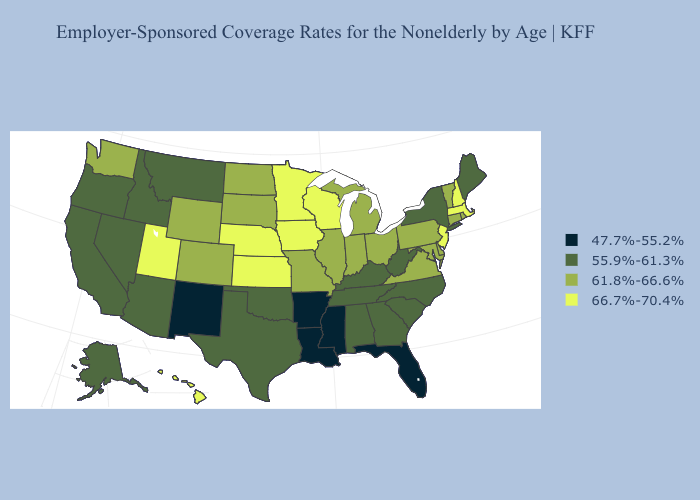What is the highest value in the USA?
Short answer required. 66.7%-70.4%. What is the highest value in the USA?
Give a very brief answer. 66.7%-70.4%. Name the states that have a value in the range 61.8%-66.6%?
Short answer required. Colorado, Connecticut, Delaware, Illinois, Indiana, Maryland, Michigan, Missouri, North Dakota, Ohio, Pennsylvania, Rhode Island, South Dakota, Vermont, Virginia, Washington, Wyoming. What is the highest value in states that border Arkansas?
Short answer required. 61.8%-66.6%. Does Massachusetts have the highest value in the USA?
Give a very brief answer. Yes. What is the value of Nevada?
Write a very short answer. 55.9%-61.3%. Which states have the lowest value in the South?
Short answer required. Arkansas, Florida, Louisiana, Mississippi. Name the states that have a value in the range 47.7%-55.2%?
Be succinct. Arkansas, Florida, Louisiana, Mississippi, New Mexico. Does North Dakota have the lowest value in the USA?
Keep it brief. No. Among the states that border Colorado , which have the highest value?
Quick response, please. Kansas, Nebraska, Utah. Does New Jersey have the highest value in the Northeast?
Be succinct. Yes. Name the states that have a value in the range 66.7%-70.4%?
Give a very brief answer. Hawaii, Iowa, Kansas, Massachusetts, Minnesota, Nebraska, New Hampshire, New Jersey, Utah, Wisconsin. What is the value of South Carolina?
Quick response, please. 55.9%-61.3%. What is the highest value in states that border Idaho?
Quick response, please. 66.7%-70.4%. What is the value of Alabama?
Write a very short answer. 55.9%-61.3%. 